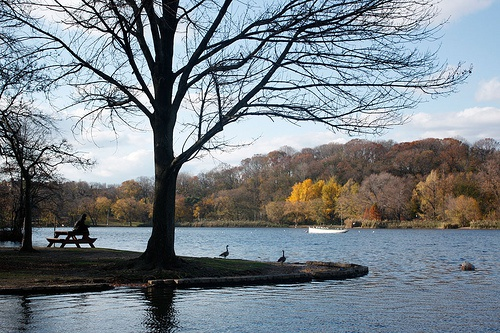Describe the objects in this image and their specific colors. I can see bench in darkgray, black, and gray tones, boat in darkgray, white, and gray tones, people in darkgray, black, and gray tones, bird in darkgray, black, and gray tones, and bird in darkgray, black, blue, and gray tones in this image. 